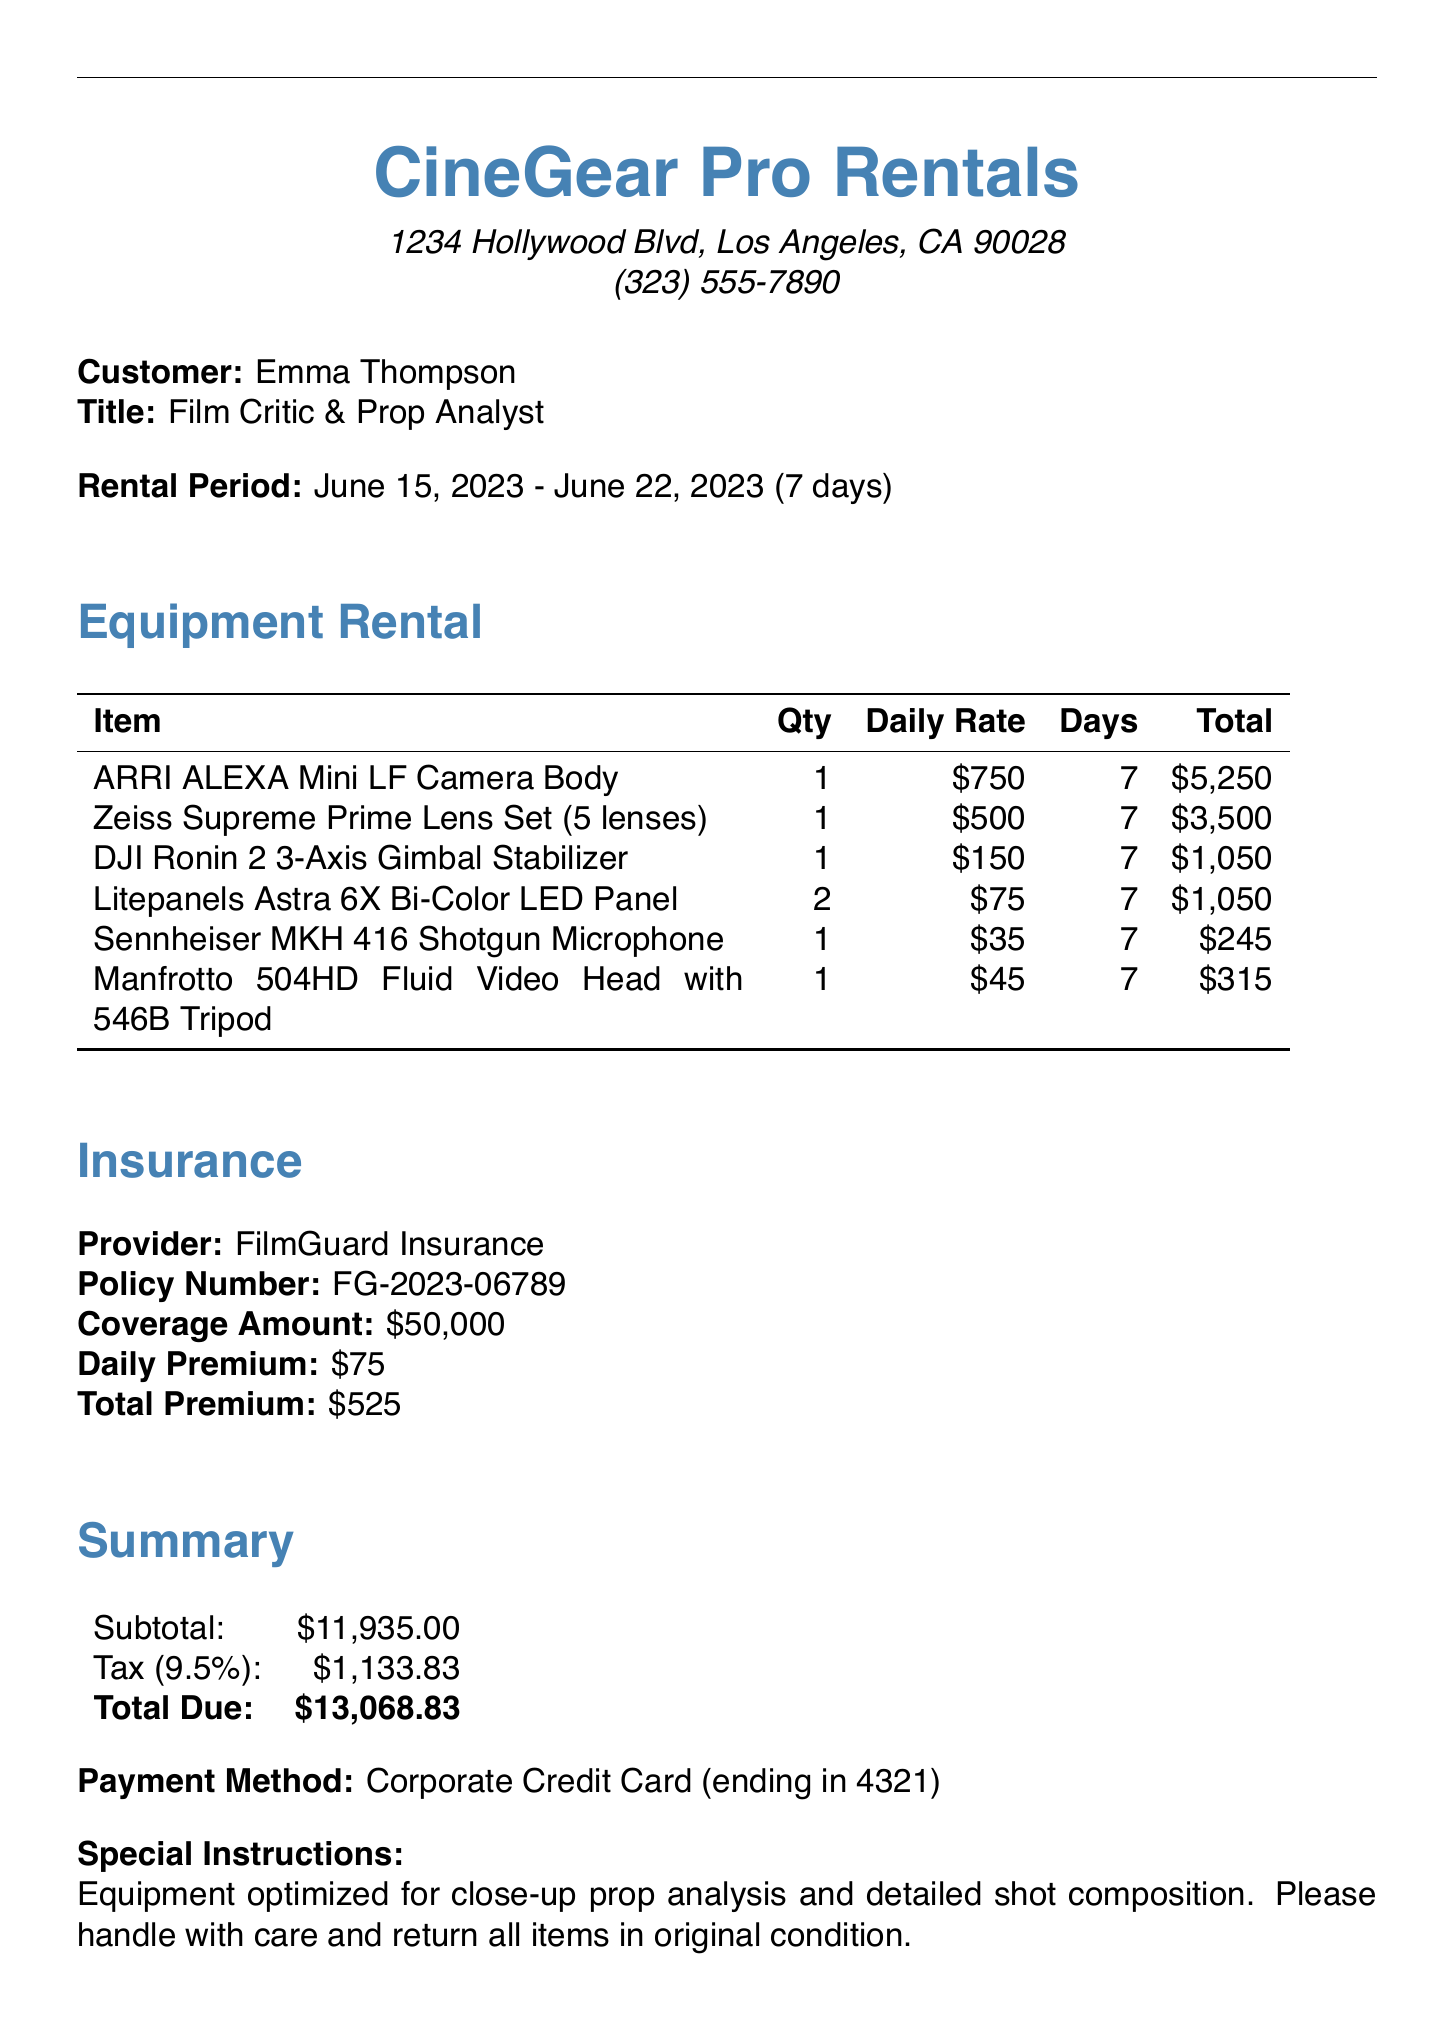What is the name of the rental company? The document lists "CineGear Pro Rentals" as the rental company.
Answer: CineGear Pro Rentals Who is the customer? The customer's name is given as "Emma Thompson" in the document.
Answer: Emma Thompson What is the total amount due? The document states the total due amount as "$13,068.83".
Answer: $13,068.83 What is the rental period? The rental period is specified as "June 15, 2023 - June 22, 2023".
Answer: June 15, 2023 - June 22, 2023 How many days is the rental duration? The document states that the rental duration is "7 days".
Answer: 7 days What is the coverage amount of the insurance? The insurance coverage amount is mentioned as "$50,000".
Answer: $50,000 What item has the highest daily rate? The item with the highest daily rate is the "ARRI ALEXA Mini LF Camera Body" at $750.
Answer: ARRI ALEXA Mini LF Camera Body What type of equipment is specified for use? The special instructions state that the equipment is "optimized for close-up prop analysis".
Answer: optimized for close-up prop analysis What is the daily premium for insurance? The document indicates the daily insurance premium as "$75".
Answer: $75 